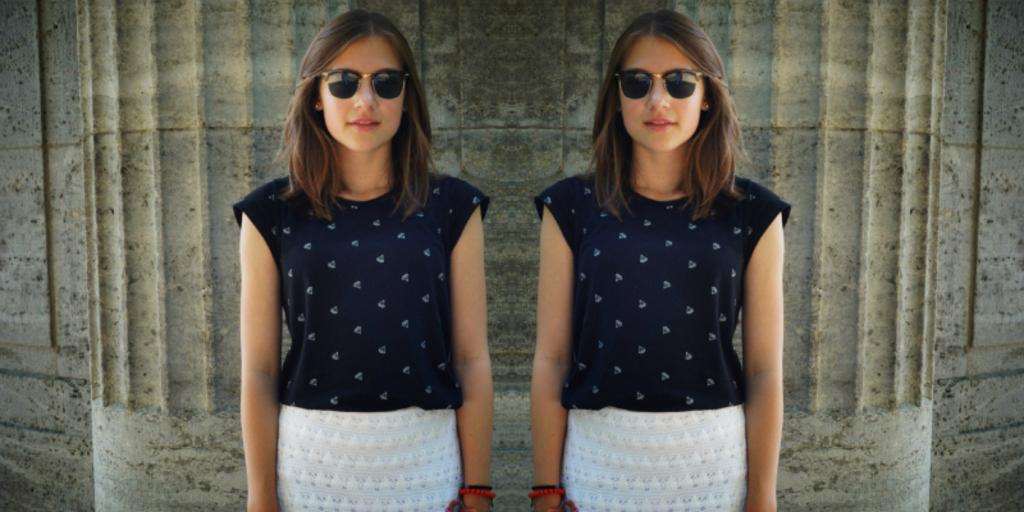How many women are in the image? There are two women in the image. What are the women doing in the image? Both women are standing. Can you describe the clothing and accessories of the women? One woman is wearing a blue dress and glasses, while the other woman is wearing a white dress and glasses. What can be seen in the background of the image? There is a wall visible in the background of the image. How many kittens are playing with the riddle on the wall in the image? There are no kittens or riddles present in the image. What type of cow can be seen grazing in the background of the image? There is no cow visible in the background of the image. 